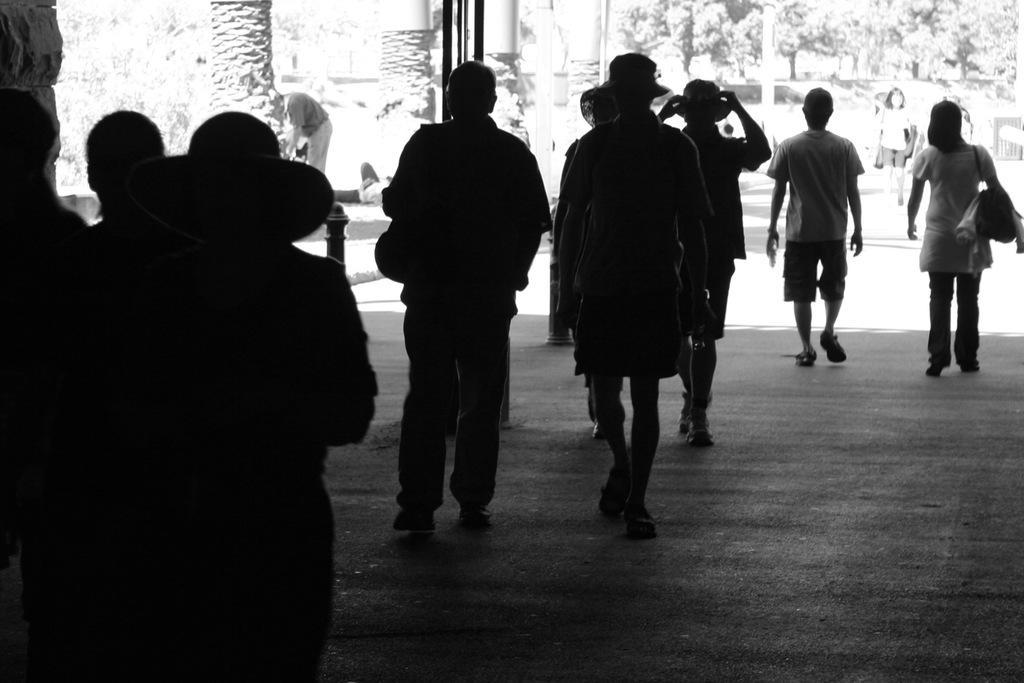Please provide a concise description of this image. In this image there is road towards the bottom of the image, there are a group of men walking on the road, there are a group of women walking on the road, there are men wearing hats, there is a woman wearing a hat, there is a man wearing a bag, there is a woman wearing a bag, there are poles towards the top of the image, there are pillars towards the top of the image, there are trees towards the top of the image, there is an object towards the left of the image. 